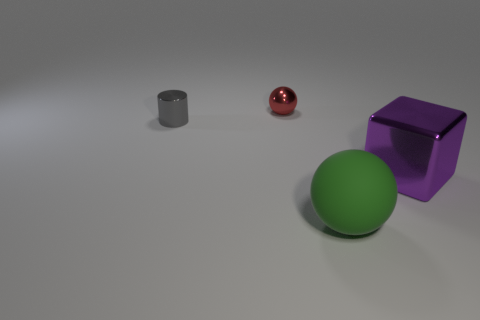The object that is both on the left side of the large ball and right of the tiny cylinder has what shape?
Your answer should be very brief. Sphere. Is there a green ball that has the same size as the purple shiny thing?
Provide a short and direct response. Yes. The small metal thing right of the gray thing behind the object in front of the large purple metal block is what shape?
Your response must be concise. Sphere. Are there more red things that are in front of the tiny gray cylinder than cylinders?
Give a very brief answer. No. Is there another thing of the same shape as the big green matte object?
Provide a succinct answer. Yes. Are the big ball and the tiny thing that is in front of the metallic ball made of the same material?
Ensure brevity in your answer.  No. The cube has what color?
Offer a very short reply. Purple. There is a rubber sphere to the right of the ball that is behind the cylinder; how many big green matte things are left of it?
Your answer should be compact. 0. Are there any large green things right of the large metallic object?
Your response must be concise. No. What number of other small gray cylinders are the same material as the tiny cylinder?
Make the answer very short. 0. 